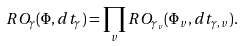Convert formula to latex. <formula><loc_0><loc_0><loc_500><loc_500>R O _ { \gamma } ( \Phi , d t _ { \gamma } ) = \prod _ { v } R O _ { \gamma _ { v } } ( \Phi _ { v } , d t _ { \gamma , v } ) .</formula> 